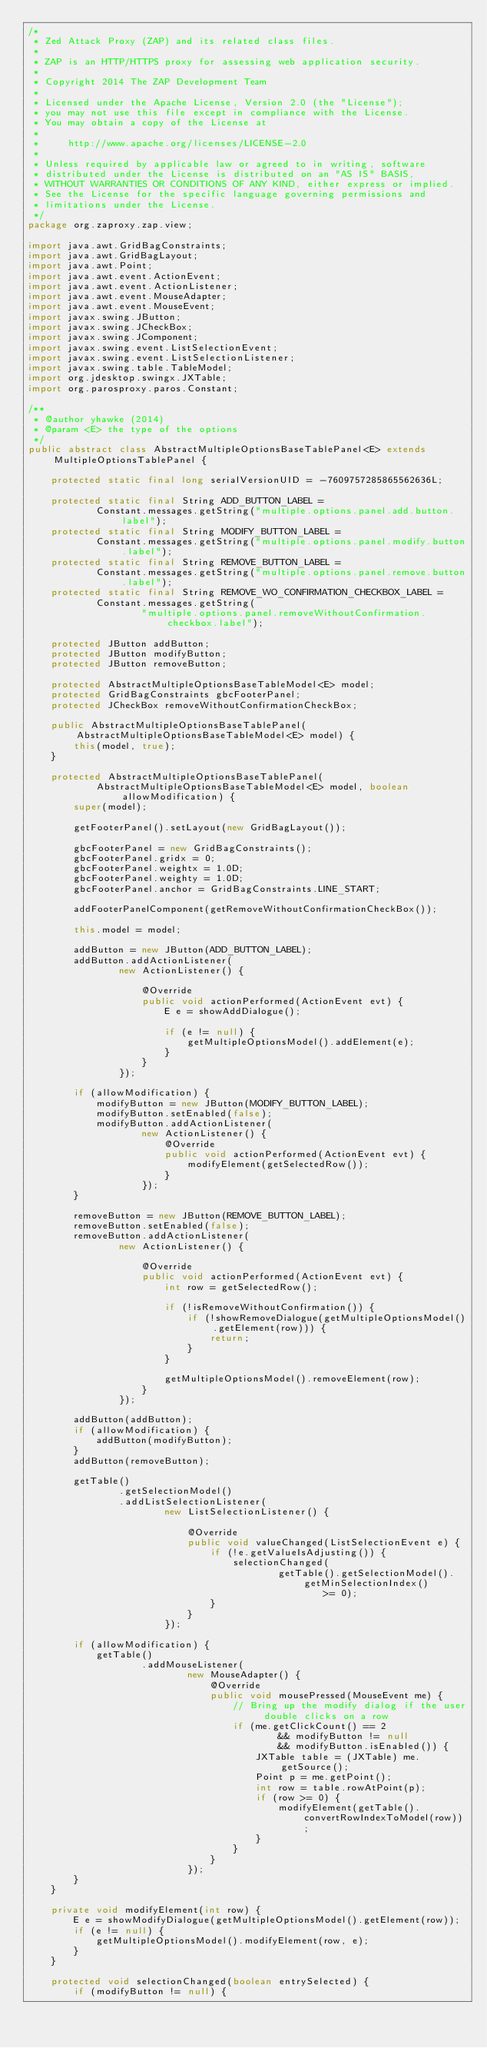Convert code to text. <code><loc_0><loc_0><loc_500><loc_500><_Java_>/*
 * Zed Attack Proxy (ZAP) and its related class files.
 *
 * ZAP is an HTTP/HTTPS proxy for assessing web application security.
 *
 * Copyright 2014 The ZAP Development Team
 *
 * Licensed under the Apache License, Version 2.0 (the "License");
 * you may not use this file except in compliance with the License.
 * You may obtain a copy of the License at
 *
 *     http://www.apache.org/licenses/LICENSE-2.0
 *
 * Unless required by applicable law or agreed to in writing, software
 * distributed under the License is distributed on an "AS IS" BASIS,
 * WITHOUT WARRANTIES OR CONDITIONS OF ANY KIND, either express or implied.
 * See the License for the specific language governing permissions and
 * limitations under the License.
 */
package org.zaproxy.zap.view;

import java.awt.GridBagConstraints;
import java.awt.GridBagLayout;
import java.awt.Point;
import java.awt.event.ActionEvent;
import java.awt.event.ActionListener;
import java.awt.event.MouseAdapter;
import java.awt.event.MouseEvent;
import javax.swing.JButton;
import javax.swing.JCheckBox;
import javax.swing.JComponent;
import javax.swing.event.ListSelectionEvent;
import javax.swing.event.ListSelectionListener;
import javax.swing.table.TableModel;
import org.jdesktop.swingx.JXTable;
import org.parosproxy.paros.Constant;

/**
 * @author yhawke (2014)
 * @param <E> the type of the options
 */
public abstract class AbstractMultipleOptionsBaseTablePanel<E> extends MultipleOptionsTablePanel {

    protected static final long serialVersionUID = -7609757285865562636L;

    protected static final String ADD_BUTTON_LABEL =
            Constant.messages.getString("multiple.options.panel.add.button.label");
    protected static final String MODIFY_BUTTON_LABEL =
            Constant.messages.getString("multiple.options.panel.modify.button.label");
    protected static final String REMOVE_BUTTON_LABEL =
            Constant.messages.getString("multiple.options.panel.remove.button.label");
    protected static final String REMOVE_WO_CONFIRMATION_CHECKBOX_LABEL =
            Constant.messages.getString(
                    "multiple.options.panel.removeWithoutConfirmation.checkbox.label");

    protected JButton addButton;
    protected JButton modifyButton;
    protected JButton removeButton;

    protected AbstractMultipleOptionsBaseTableModel<E> model;
    protected GridBagConstraints gbcFooterPanel;
    protected JCheckBox removeWithoutConfirmationCheckBox;

    public AbstractMultipleOptionsBaseTablePanel(AbstractMultipleOptionsBaseTableModel<E> model) {
        this(model, true);
    }

    protected AbstractMultipleOptionsBaseTablePanel(
            AbstractMultipleOptionsBaseTableModel<E> model, boolean allowModification) {
        super(model);

        getFooterPanel().setLayout(new GridBagLayout());

        gbcFooterPanel = new GridBagConstraints();
        gbcFooterPanel.gridx = 0;
        gbcFooterPanel.weightx = 1.0D;
        gbcFooterPanel.weighty = 1.0D;
        gbcFooterPanel.anchor = GridBagConstraints.LINE_START;

        addFooterPanelComponent(getRemoveWithoutConfirmationCheckBox());

        this.model = model;

        addButton = new JButton(ADD_BUTTON_LABEL);
        addButton.addActionListener(
                new ActionListener() {

                    @Override
                    public void actionPerformed(ActionEvent evt) {
                        E e = showAddDialogue();

                        if (e != null) {
                            getMultipleOptionsModel().addElement(e);
                        }
                    }
                });

        if (allowModification) {
            modifyButton = new JButton(MODIFY_BUTTON_LABEL);
            modifyButton.setEnabled(false);
            modifyButton.addActionListener(
                    new ActionListener() {
                        @Override
                        public void actionPerformed(ActionEvent evt) {
                            modifyElement(getSelectedRow());
                        }
                    });
        }

        removeButton = new JButton(REMOVE_BUTTON_LABEL);
        removeButton.setEnabled(false);
        removeButton.addActionListener(
                new ActionListener() {

                    @Override
                    public void actionPerformed(ActionEvent evt) {
                        int row = getSelectedRow();

                        if (!isRemoveWithoutConfirmation()) {
                            if (!showRemoveDialogue(getMultipleOptionsModel().getElement(row))) {
                                return;
                            }
                        }

                        getMultipleOptionsModel().removeElement(row);
                    }
                });

        addButton(addButton);
        if (allowModification) {
            addButton(modifyButton);
        }
        addButton(removeButton);

        getTable()
                .getSelectionModel()
                .addListSelectionListener(
                        new ListSelectionListener() {

                            @Override
                            public void valueChanged(ListSelectionEvent e) {
                                if (!e.getValueIsAdjusting()) {
                                    selectionChanged(
                                            getTable().getSelectionModel().getMinSelectionIndex()
                                                    >= 0);
                                }
                            }
                        });

        if (allowModification) {
            getTable()
                    .addMouseListener(
                            new MouseAdapter() {
                                @Override
                                public void mousePressed(MouseEvent me) {
                                    // Bring up the modify dialog if the user double clicks on a row
                                    if (me.getClickCount() == 2
                                            && modifyButton != null
                                            && modifyButton.isEnabled()) {
                                        JXTable table = (JXTable) me.getSource();
                                        Point p = me.getPoint();
                                        int row = table.rowAtPoint(p);
                                        if (row >= 0) {
                                            modifyElement(getTable().convertRowIndexToModel(row));
                                        }
                                    }
                                }
                            });
        }
    }

    private void modifyElement(int row) {
        E e = showModifyDialogue(getMultipleOptionsModel().getElement(row));
        if (e != null) {
            getMultipleOptionsModel().modifyElement(row, e);
        }
    }

    protected void selectionChanged(boolean entrySelected) {
        if (modifyButton != null) {</code> 